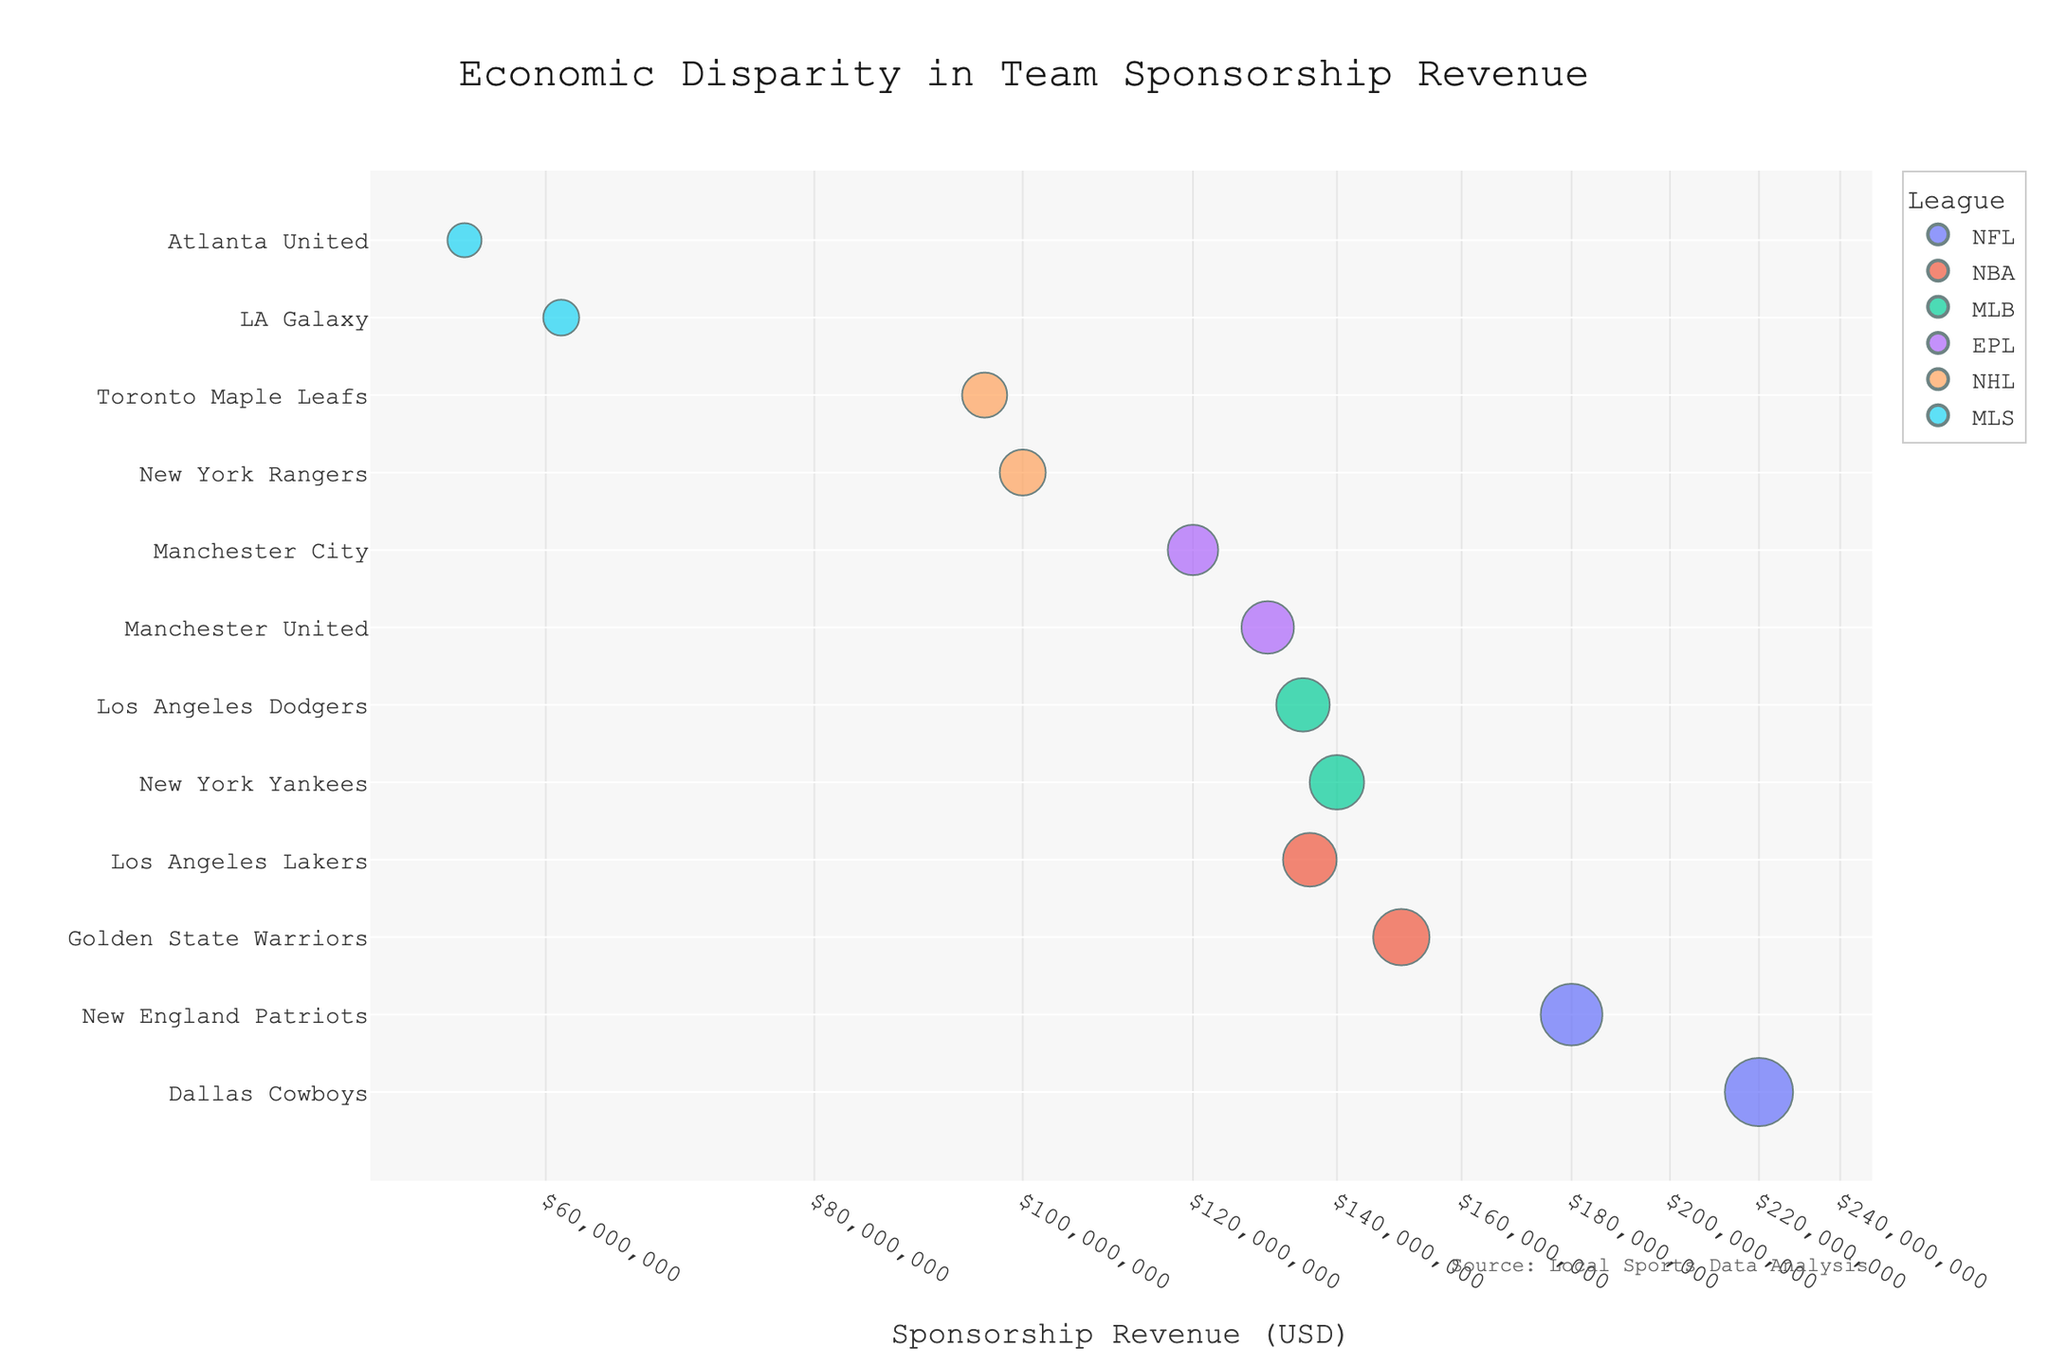What is the title of the scatter plot? The title of the scatter plot is usually displayed at the top of the figure and is a direct text element.
Answer: Economic Disparity in Team Sponsorship Revenue Which team in the NFL has the highest sponsorship revenue, and how much is it? Finding the team with the highest sponsorship revenue in a league involves identifying the point representing the top revenue and checking the league for that point's color or label marked "NFL".
Answer: Dallas Cowboys, $220,000,000 How many teams are represented in the plot from the NBA? To determine the number of NBA teams, count the data points that are color-coded or labeled as belonging to the NBA.
Answer: 2 Between the New York Yankees and the Los Angeles Dodgers, which team has greater sponsorship revenue and by how much? Compare the sponsorship revenues for the New York Yankees and the Los Angeles Dodgers from the plot. The team with the higher value is then noted along with the difference.
Answer: New York Yankees, $5,000,000 What is the approximate difference in sponsorship revenue between the highest-earning team in the EPL and the lowest-earning team in the MLS? Identify the maximum sponsorship revenue for an EPL team and the minimum for an MLS team from the plot, then subtract the smaller from the larger.
Answer: $75,000,000 Which league has the team with the third highest sponsorship revenue? Arrange the teams in descending order based on sponsorship revenue and identify the league of the third team on the list.
Answer: NBA Is the sponsorship revenue of the New York Rangers closer to that of the Toronto Maple Leafs or the LA Galaxy? Compare the sponsorship revenues of the New York Rangers, Toronto Maple Leafs, and LA Galaxy and see which difference is smaller.
Answer: Toronto Maple Leafs Between Manchester United and Manchester City, which team has lower sponsorship revenue, and by how much? Check the sponsorship revenues for Manchester United and Manchester City in the plot. The team with the lower revenue is noted along with the difference.
Answer: Manchester City, $10,000,000 What is the median value of the sponsorship revenue across all teams plotted? List all sponsorship revenues in ascending order and find the middle value. If the number of data points is even, average the two middle values.
Answer: $128,000,000 How many teams have sponsorship revenues exceeding $100,000,000? Count the number of data points that are positioned past the $100,000,000 mark on the log scale x-axis.
Answer: 7 